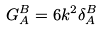<formula> <loc_0><loc_0><loc_500><loc_500>G _ { A } ^ { B } = 6 k ^ { 2 } \delta _ { A } ^ { B }</formula> 